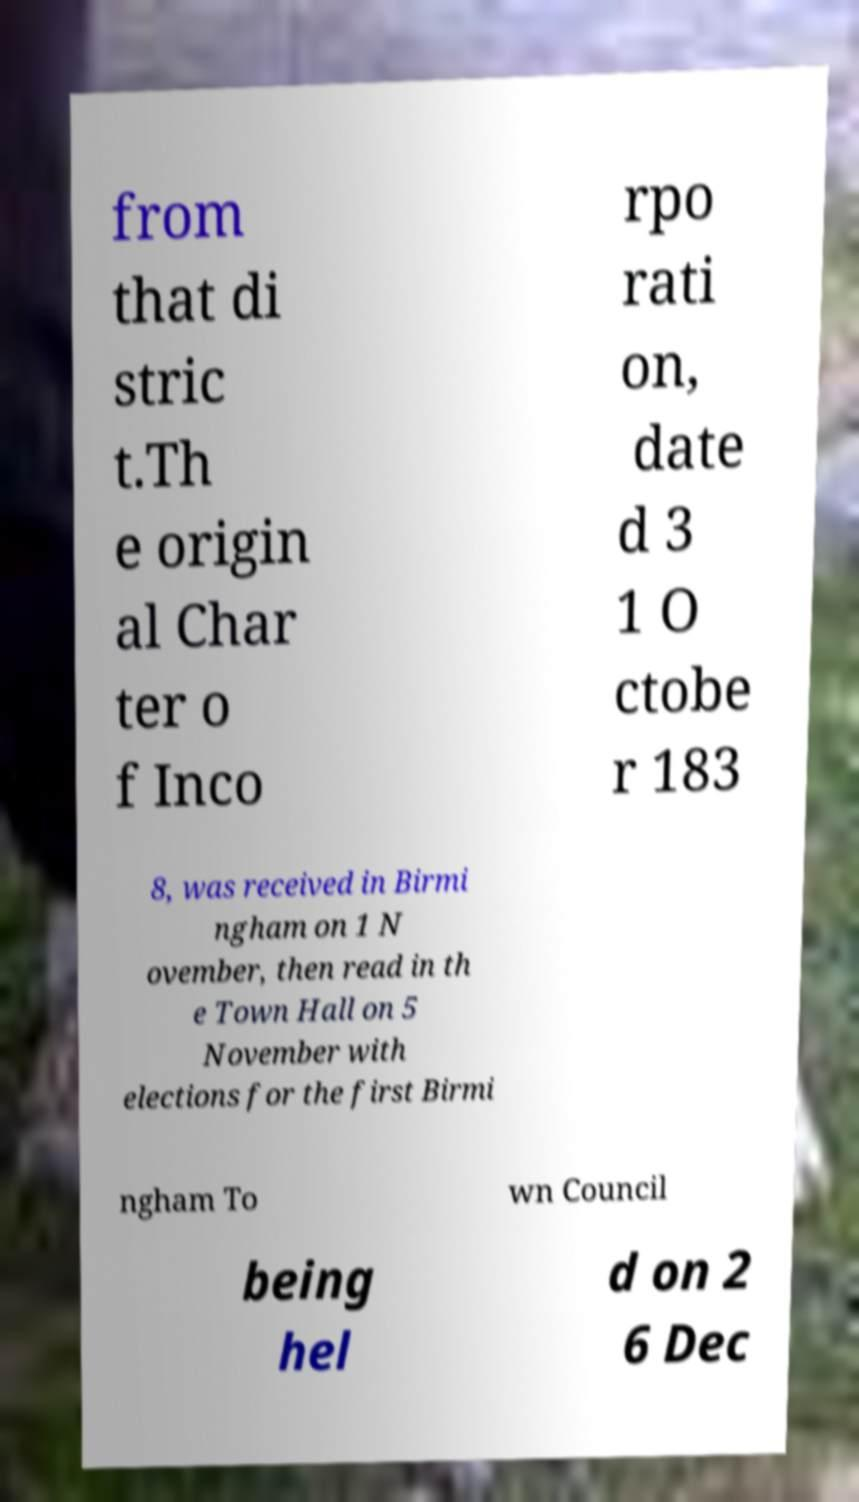I need the written content from this picture converted into text. Can you do that? from that di stric t.Th e origin al Char ter o f Inco rpo rati on, date d 3 1 O ctobe r 183 8, was received in Birmi ngham on 1 N ovember, then read in th e Town Hall on 5 November with elections for the first Birmi ngham To wn Council being hel d on 2 6 Dec 